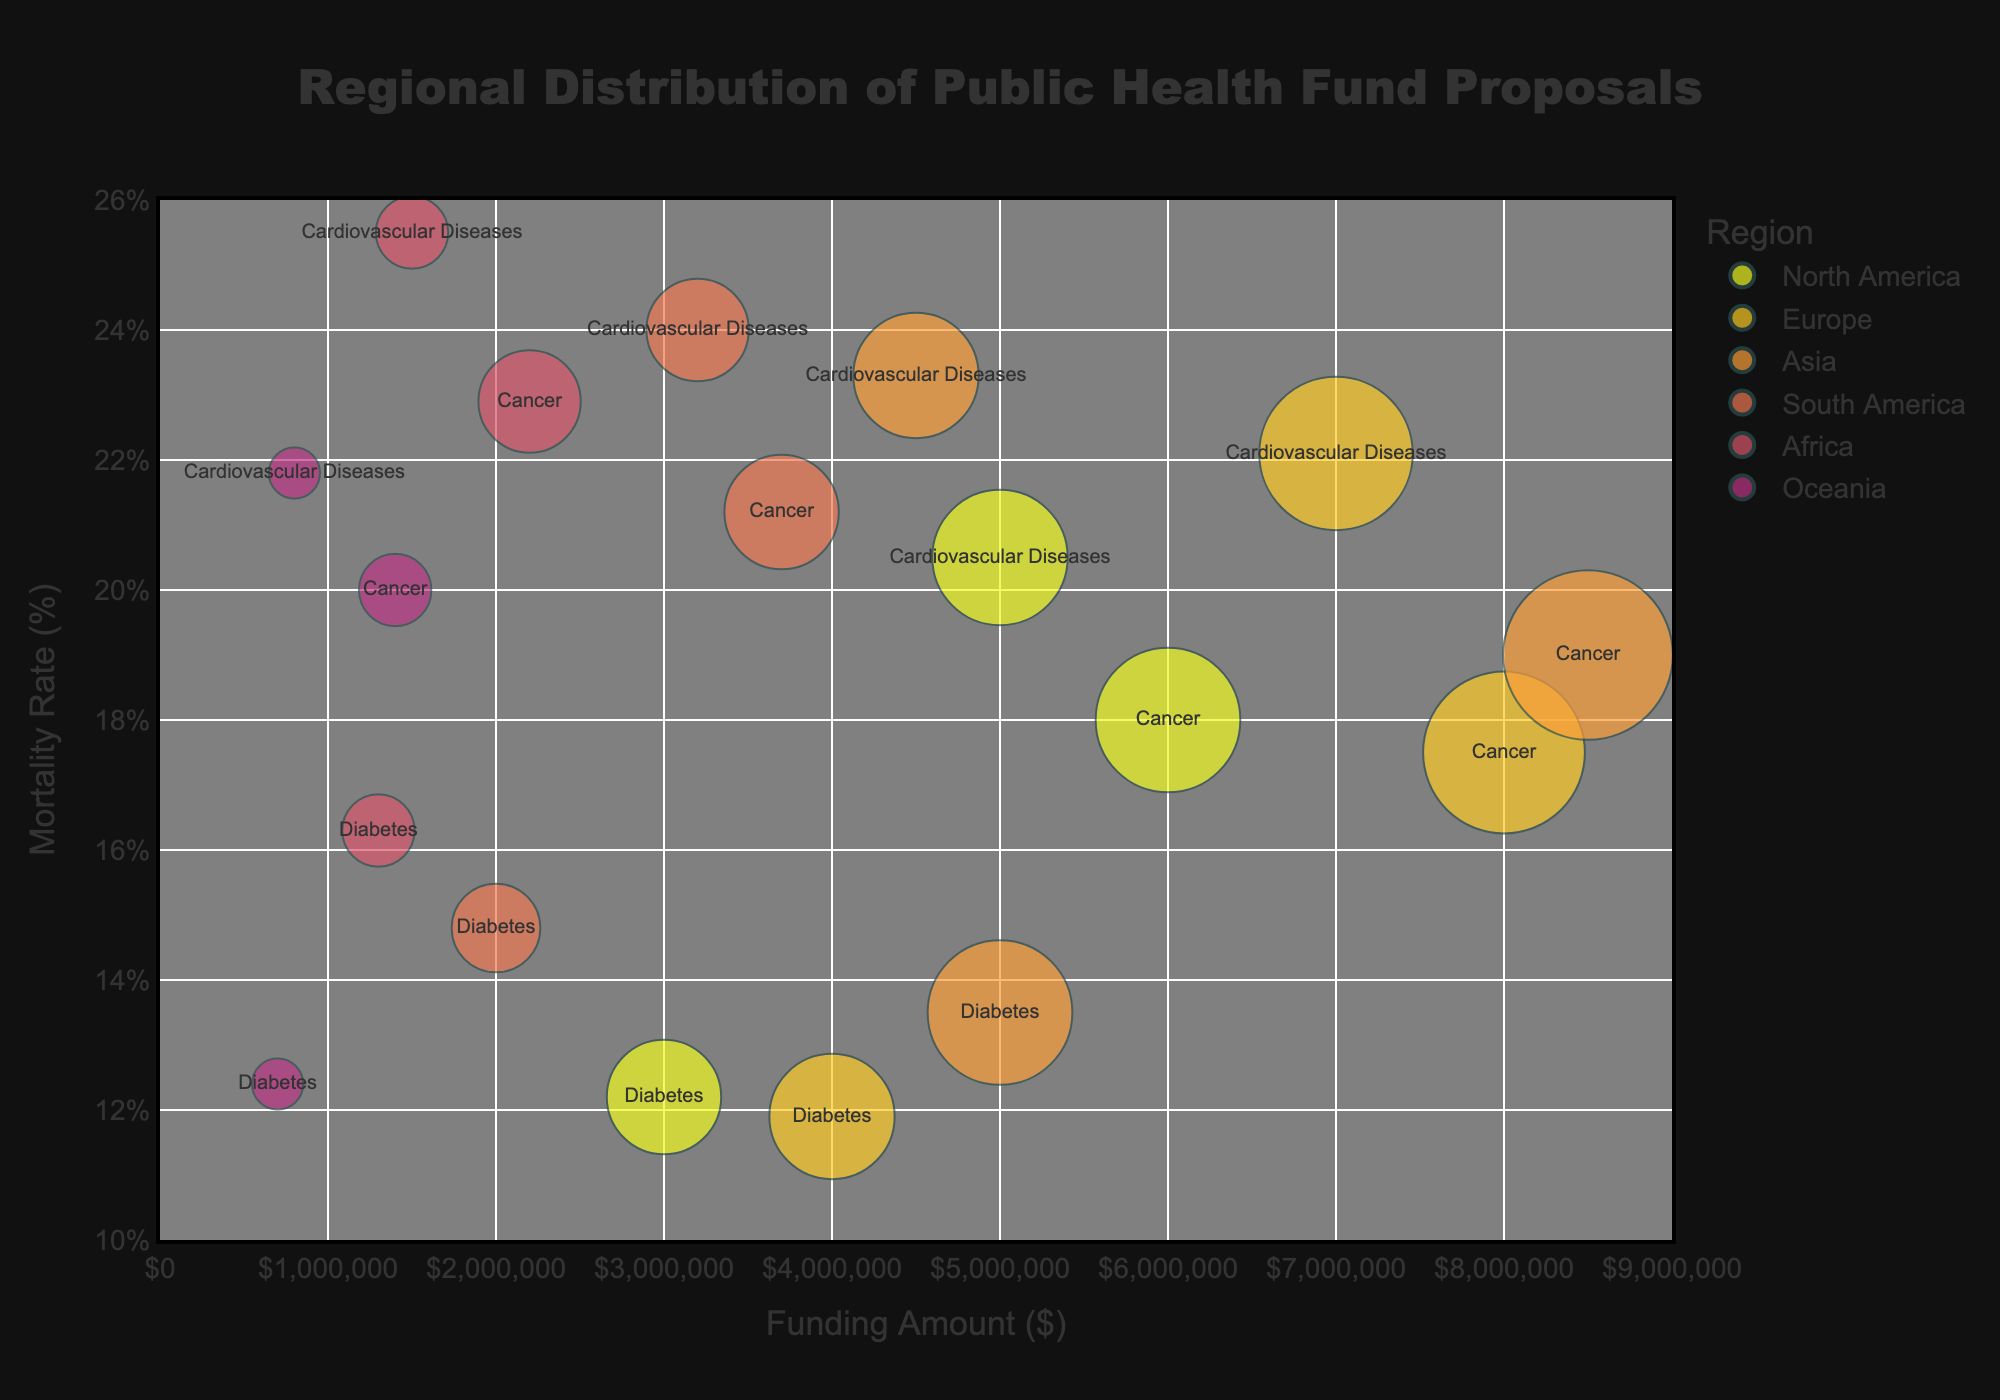What is the title of the bubble chart? The title of the bubble chart is located at the top center and is styled in large, bold font. It reads "Regional Distribution of Public Health Fund Proposals."
Answer: Regional Distribution of Public Health Fund Proposals What does the x-axis represent? The x-axis represents the "Funding Amount" and is measured in dollars ($). This is indicated by the axis title below the x-axis.
Answer: Funding Amount Which region has the highest funding amount for cancer proposals? By examining the bubbles, we identify the one with the highest x-axis value for cancer (hover text). The highest funding amount for cancer proposals is in Asia.
Answer: Asia Which region has the largest number of proposals for diabetes? The size of the bubbles represents the Number of Proposals. The largest bubble among those labeled "Diabetes" belongs to Asia.
Answer: Asia What is the mortality rate for cardiovascular diseases in Oceania? By identifying the bubble labeled "Cardiovascular Diseases" in the Oceania region, we see it is positioned at a mortality rate of 21.8%.
Answer: 21.8% How many proposals are there in total for cancer across all regions? Sum the "Number of Proposals" for cancer bubbles in all regions: 40 (North America) + 50 (Europe) + 55 (Asia) + 25 (South America) + 20 (Africa) + 10 (Oceania).
Answer: 200 Which disease has the highest mortality rate in North America? By comparing the y-axis positions of bubbles labeled "Cardiovascular Diseases," "Cancer," and "Diabetes" in the North America region, "Cardiovascular Diseases" has the highest position at 20.5%.
Answer: Cardiovascular Diseases What is the average mortality rate for diabetes across all regions? Add the mortality rates for diabetes in all regions and divide by the number of regions: (12.2 (North America) + 11.9 (Europe) + 13.5 (Asia) + 14.8 (South America) + 16.3 (Africa) + 12.4 (Oceania)) / 6.
Answer: 13.52% Which region has the lowest overall funding for public health proposals? The smallest bubble by size for any disease in all regions represents the funding. The smallest bubble overall belongs to Oceania (Cardiovascular Diseases).
Answer: Oceania 